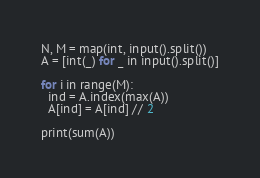<code> <loc_0><loc_0><loc_500><loc_500><_Python_>N, M = map(int, input().split())
A = [int(_) for _ in input().split()]

for i in range(M):
  ind = A.index(max(A))
  A[ind] = A[ind] // 2
  
print(sum(A))</code> 